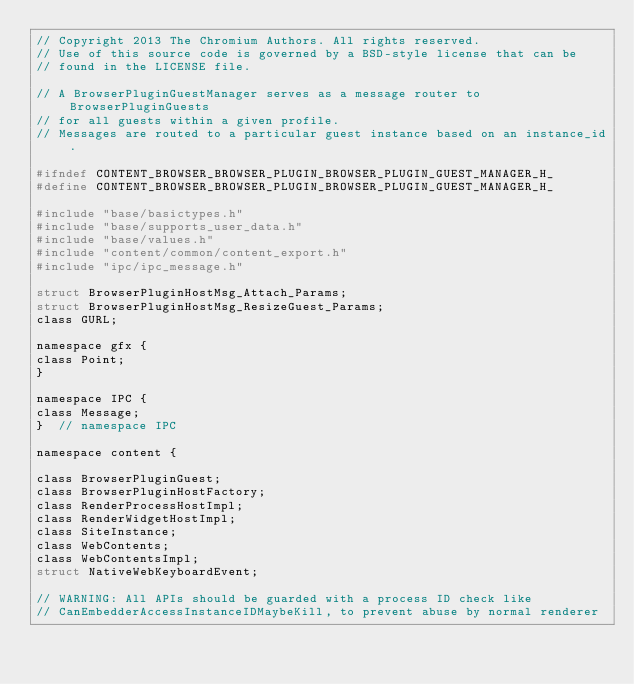<code> <loc_0><loc_0><loc_500><loc_500><_C_>// Copyright 2013 The Chromium Authors. All rights reserved.
// Use of this source code is governed by a BSD-style license that can be
// found in the LICENSE file.

// A BrowserPluginGuestManager serves as a message router to BrowserPluginGuests
// for all guests within a given profile.
// Messages are routed to a particular guest instance based on an instance_id.

#ifndef CONTENT_BROWSER_BROWSER_PLUGIN_BROWSER_PLUGIN_GUEST_MANAGER_H_
#define CONTENT_BROWSER_BROWSER_PLUGIN_BROWSER_PLUGIN_GUEST_MANAGER_H_

#include "base/basictypes.h"
#include "base/supports_user_data.h"
#include "base/values.h"
#include "content/common/content_export.h"
#include "ipc/ipc_message.h"

struct BrowserPluginHostMsg_Attach_Params;
struct BrowserPluginHostMsg_ResizeGuest_Params;
class GURL;

namespace gfx {
class Point;
}

namespace IPC {
class Message;
}  // namespace IPC

namespace content {

class BrowserPluginGuest;
class BrowserPluginHostFactory;
class RenderProcessHostImpl;
class RenderWidgetHostImpl;
class SiteInstance;
class WebContents;
class WebContentsImpl;
struct NativeWebKeyboardEvent;

// WARNING: All APIs should be guarded with a process ID check like
// CanEmbedderAccessInstanceIDMaybeKill, to prevent abuse by normal renderer</code> 